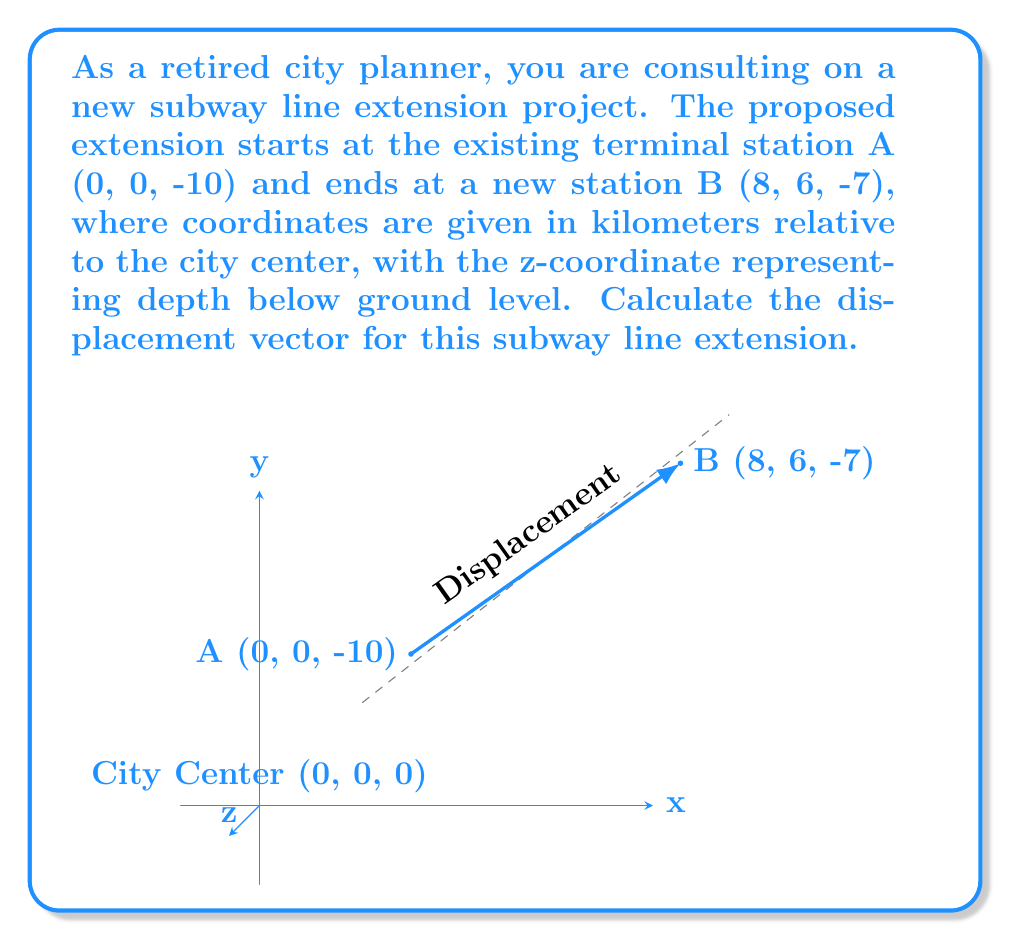Provide a solution to this math problem. To find the displacement vector, we need to calculate the difference between the final position (point B) and the initial position (point A). Let's approach this step-by-step:

1) The coordinates are given as:
   Point A: (0, 0, -10)
   Point B: (8, 6, -7)

2) The displacement vector $\vec{d}$ is calculated as:
   $$\vec{d} = \vec{B} - \vec{A}$$

3) Subtracting the coordinates:
   $$\vec{d} = (8-0, 6-0, -7-(-10))$$

4) Simplifying:
   $$\vec{d} = (8, 6, 3)$$

5) This vector represents:
   - 8 km east (x-direction)
   - 6 km north (y-direction)
   - 3 km upward (z-direction)

6) The magnitude of this vector can be calculated using the Pythagorean theorem:
   $$|\vec{d}| = \sqrt{8^2 + 6^2 + 3^2} = \sqrt{64 + 36 + 9} = \sqrt{109} \approx 10.44 \text{ km}$$

This displacement vector provides important information for city planners, such as the total straight-line distance of the extension, the change in depth, and the horizontal distance covered, which are crucial for planning construction, estimating costs, and assessing the impact on the surrounding urban area.
Answer: $\vec{d} = (8, 6, 3)$ km 